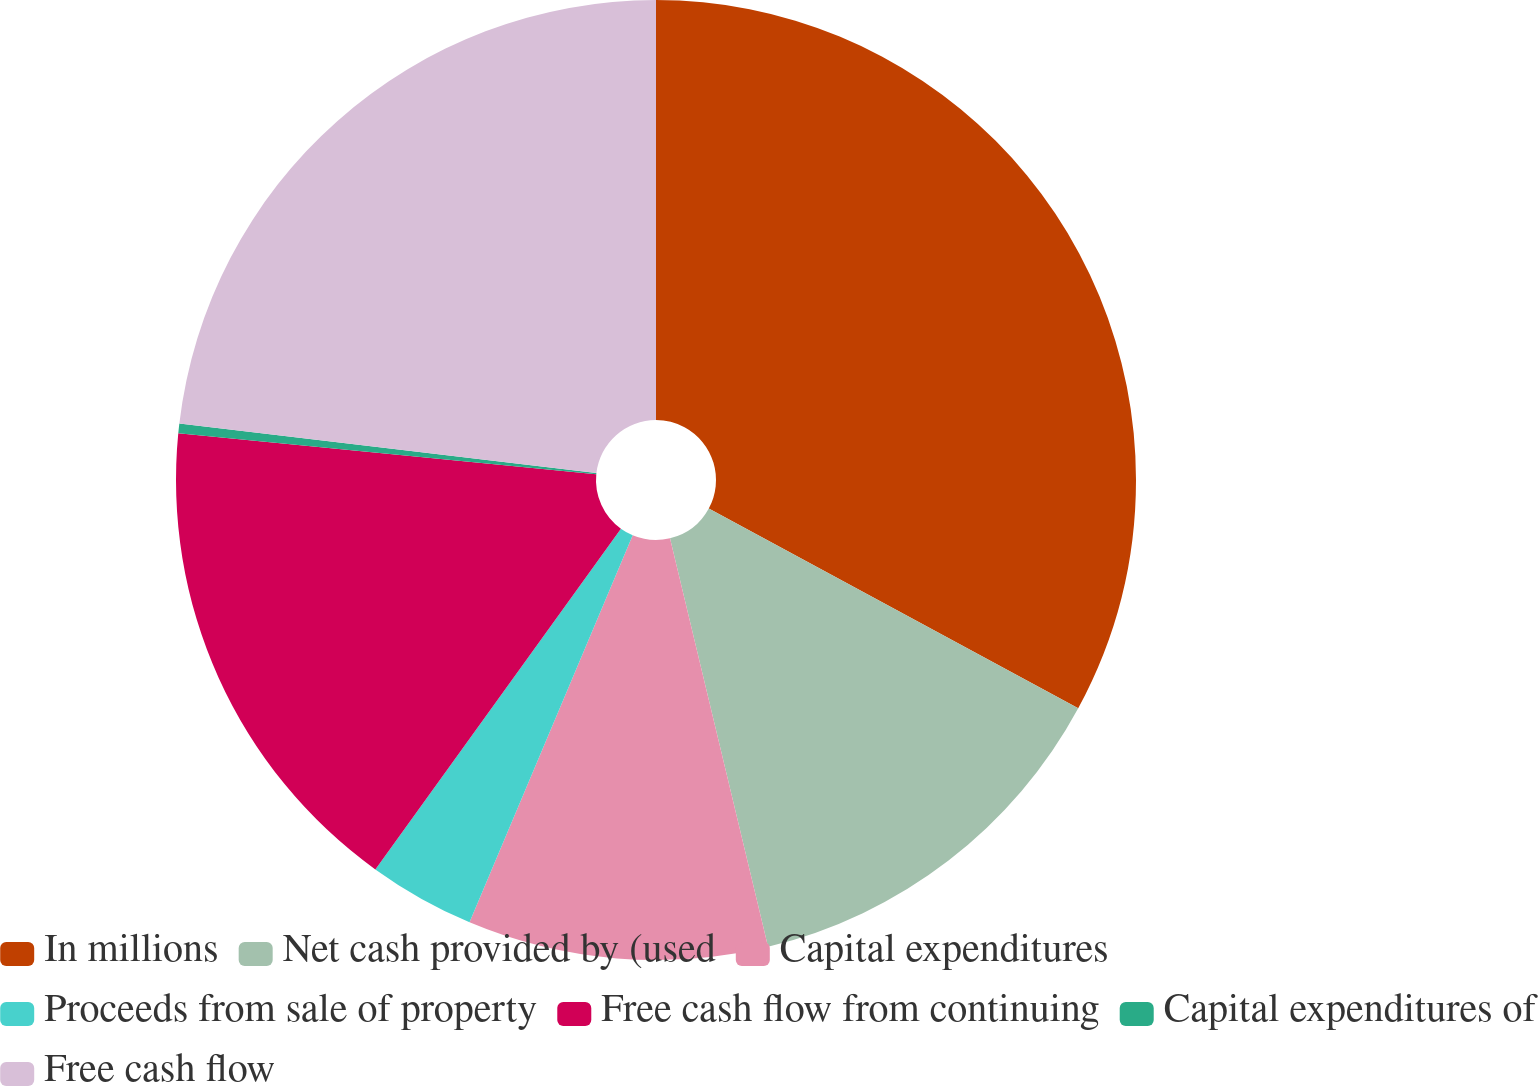Convert chart. <chart><loc_0><loc_0><loc_500><loc_500><pie_chart><fcel>In millions<fcel>Net cash provided by (used<fcel>Capital expenditures<fcel>Proceeds from sale of property<fcel>Free cash flow from continuing<fcel>Capital expenditures of<fcel>Free cash flow<nl><fcel>32.89%<fcel>13.36%<fcel>10.1%<fcel>3.59%<fcel>16.61%<fcel>0.33%<fcel>23.12%<nl></chart> 